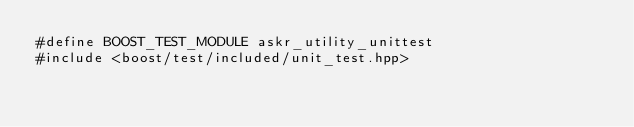<code> <loc_0><loc_0><loc_500><loc_500><_C++_>#define BOOST_TEST_MODULE askr_utility_unittest
#include <boost/test/included/unit_test.hpp>
</code> 